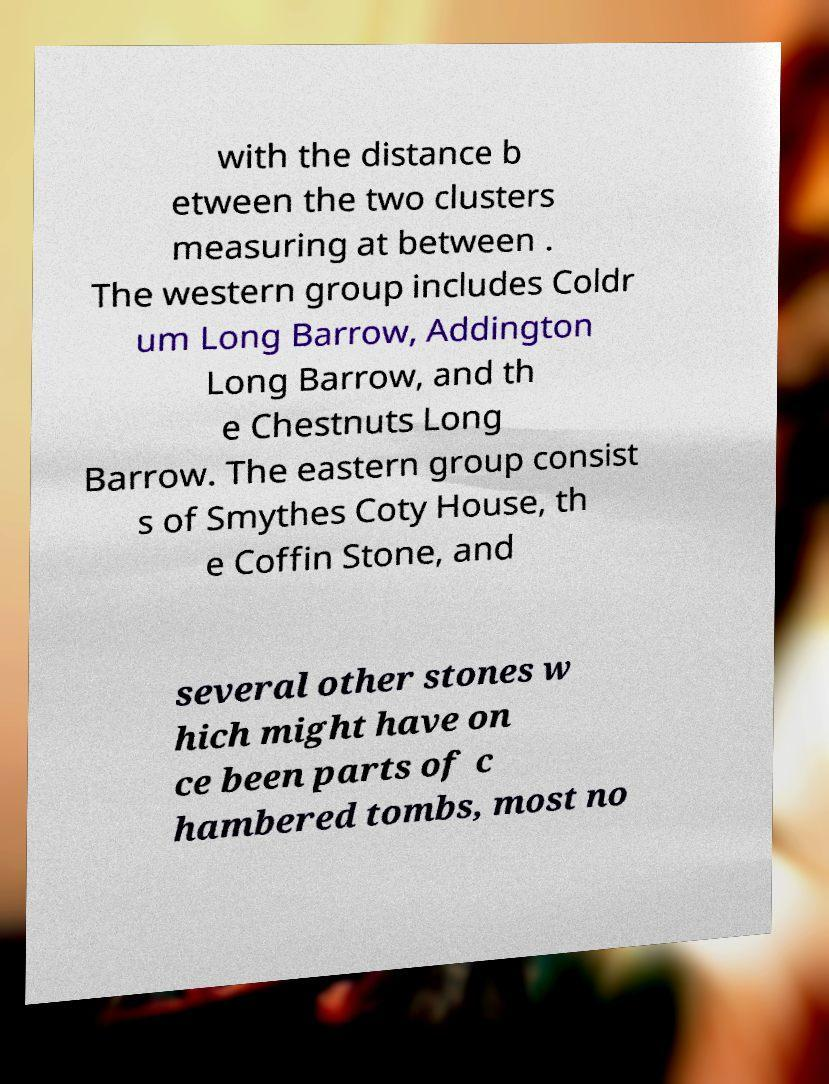Could you extract and type out the text from this image? with the distance b etween the two clusters measuring at between . The western group includes Coldr um Long Barrow, Addington Long Barrow, and th e Chestnuts Long Barrow. The eastern group consist s of Smythes Coty House, th e Coffin Stone, and several other stones w hich might have on ce been parts of c hambered tombs, most no 